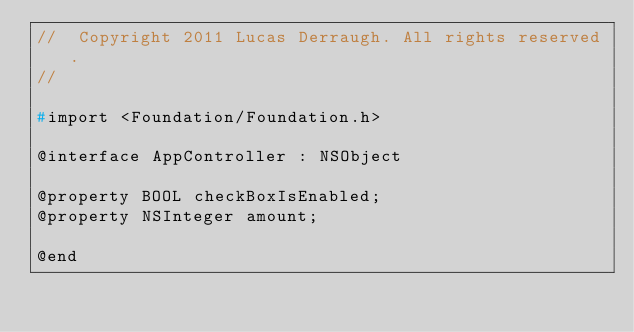Convert code to text. <code><loc_0><loc_0><loc_500><loc_500><_C_>//  Copyright 2011 Lucas Derraugh. All rights reserved.
//

#import <Foundation/Foundation.h>

@interface AppController : NSObject

@property BOOL checkBoxIsEnabled;
@property NSInteger amount;

@end
</code> 